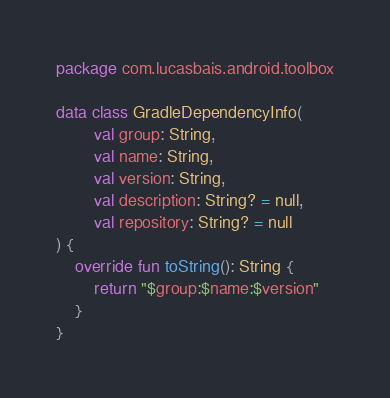<code> <loc_0><loc_0><loc_500><loc_500><_Kotlin_>package com.lucasbais.android.toolbox

data class GradleDependencyInfo(
        val group: String,
        val name: String,
        val version: String,
        val description: String? = null,
        val repository: String? = null
) {
    override fun toString(): String {
        return "$group:$name:$version"
    }
}</code> 